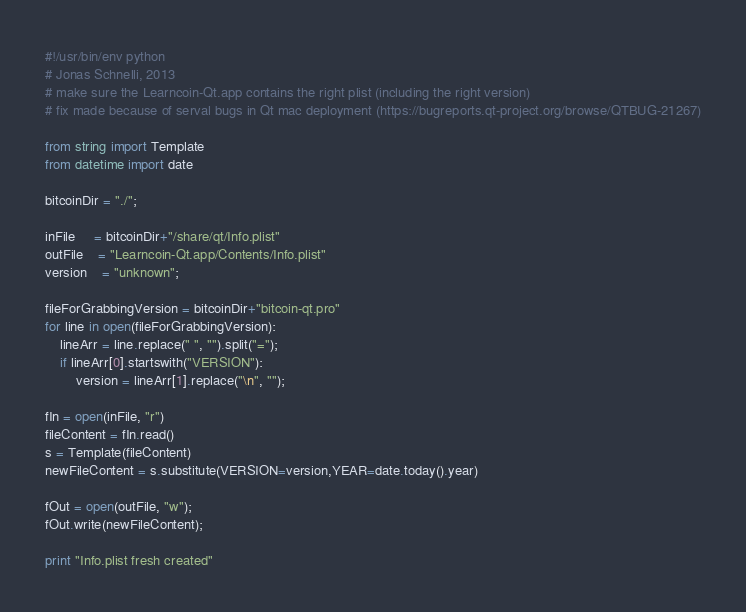<code> <loc_0><loc_0><loc_500><loc_500><_Python_>#!/usr/bin/env python
# Jonas Schnelli, 2013
# make sure the Learncoin-Qt.app contains the right plist (including the right version)
# fix made because of serval bugs in Qt mac deployment (https://bugreports.qt-project.org/browse/QTBUG-21267)

from string import Template
from datetime import date

bitcoinDir = "./";

inFile     = bitcoinDir+"/share/qt/Info.plist"
outFile    = "Learncoin-Qt.app/Contents/Info.plist"
version    = "unknown";

fileForGrabbingVersion = bitcoinDir+"bitcoin-qt.pro"
for line in open(fileForGrabbingVersion):
	lineArr = line.replace(" ", "").split("=");
	if lineArr[0].startswith("VERSION"):
		version = lineArr[1].replace("\n", "");

fIn = open(inFile, "r")
fileContent = fIn.read()
s = Template(fileContent)
newFileContent = s.substitute(VERSION=version,YEAR=date.today().year)

fOut = open(outFile, "w");
fOut.write(newFileContent);

print "Info.plist fresh created"
</code> 